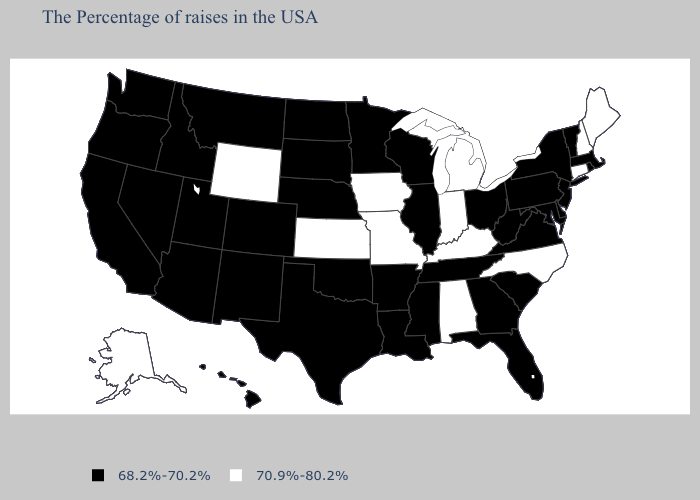What is the value of Hawaii?
Give a very brief answer. 68.2%-70.2%. Name the states that have a value in the range 70.9%-80.2%?
Short answer required. Maine, New Hampshire, Connecticut, North Carolina, Michigan, Kentucky, Indiana, Alabama, Missouri, Iowa, Kansas, Wyoming, Alaska. Name the states that have a value in the range 68.2%-70.2%?
Quick response, please. Massachusetts, Rhode Island, Vermont, New York, New Jersey, Delaware, Maryland, Pennsylvania, Virginia, South Carolina, West Virginia, Ohio, Florida, Georgia, Tennessee, Wisconsin, Illinois, Mississippi, Louisiana, Arkansas, Minnesota, Nebraska, Oklahoma, Texas, South Dakota, North Dakota, Colorado, New Mexico, Utah, Montana, Arizona, Idaho, Nevada, California, Washington, Oregon, Hawaii. Which states hav the highest value in the South?
Answer briefly. North Carolina, Kentucky, Alabama. How many symbols are there in the legend?
Be succinct. 2. Is the legend a continuous bar?
Short answer required. No. What is the value of Oregon?
Concise answer only. 68.2%-70.2%. What is the lowest value in the USA?
Concise answer only. 68.2%-70.2%. Name the states that have a value in the range 68.2%-70.2%?
Give a very brief answer. Massachusetts, Rhode Island, Vermont, New York, New Jersey, Delaware, Maryland, Pennsylvania, Virginia, South Carolina, West Virginia, Ohio, Florida, Georgia, Tennessee, Wisconsin, Illinois, Mississippi, Louisiana, Arkansas, Minnesota, Nebraska, Oklahoma, Texas, South Dakota, North Dakota, Colorado, New Mexico, Utah, Montana, Arizona, Idaho, Nevada, California, Washington, Oregon, Hawaii. Name the states that have a value in the range 68.2%-70.2%?
Concise answer only. Massachusetts, Rhode Island, Vermont, New York, New Jersey, Delaware, Maryland, Pennsylvania, Virginia, South Carolina, West Virginia, Ohio, Florida, Georgia, Tennessee, Wisconsin, Illinois, Mississippi, Louisiana, Arkansas, Minnesota, Nebraska, Oklahoma, Texas, South Dakota, North Dakota, Colorado, New Mexico, Utah, Montana, Arizona, Idaho, Nevada, California, Washington, Oregon, Hawaii. What is the value of Colorado?
Keep it brief. 68.2%-70.2%. What is the highest value in the MidWest ?
Short answer required. 70.9%-80.2%. Name the states that have a value in the range 70.9%-80.2%?
Give a very brief answer. Maine, New Hampshire, Connecticut, North Carolina, Michigan, Kentucky, Indiana, Alabama, Missouri, Iowa, Kansas, Wyoming, Alaska. Which states hav the highest value in the West?
Keep it brief. Wyoming, Alaska. 